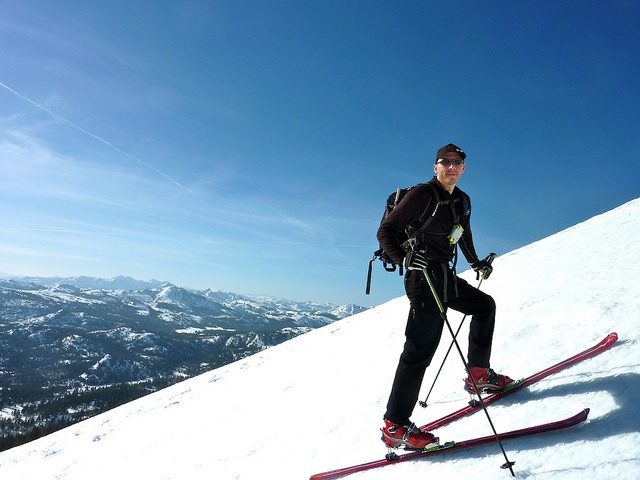Describe the objects in this image and their specific colors. I can see people in gray, black, maroon, and white tones, skis in gray, black, white, and maroon tones, backpack in gray, black, and darkgray tones, and backpack in gray, black, and lightblue tones in this image. 